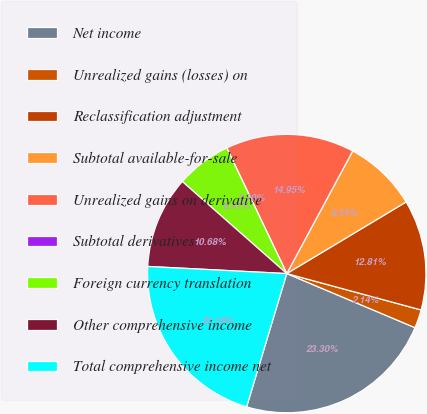<chart> <loc_0><loc_0><loc_500><loc_500><pie_chart><fcel>Net income<fcel>Unrealized gains (losses) on<fcel>Reclassification adjustment<fcel>Subtotal available-for-sale<fcel>Unrealized gains on derivative<fcel>Subtotal derivatives<fcel>Foreign currency translation<fcel>Other comprehensive income<fcel>Total comprehensive income net<nl><fcel>23.3%<fcel>2.14%<fcel>12.81%<fcel>8.54%<fcel>14.95%<fcel>0.0%<fcel>6.41%<fcel>10.68%<fcel>21.16%<nl></chart> 